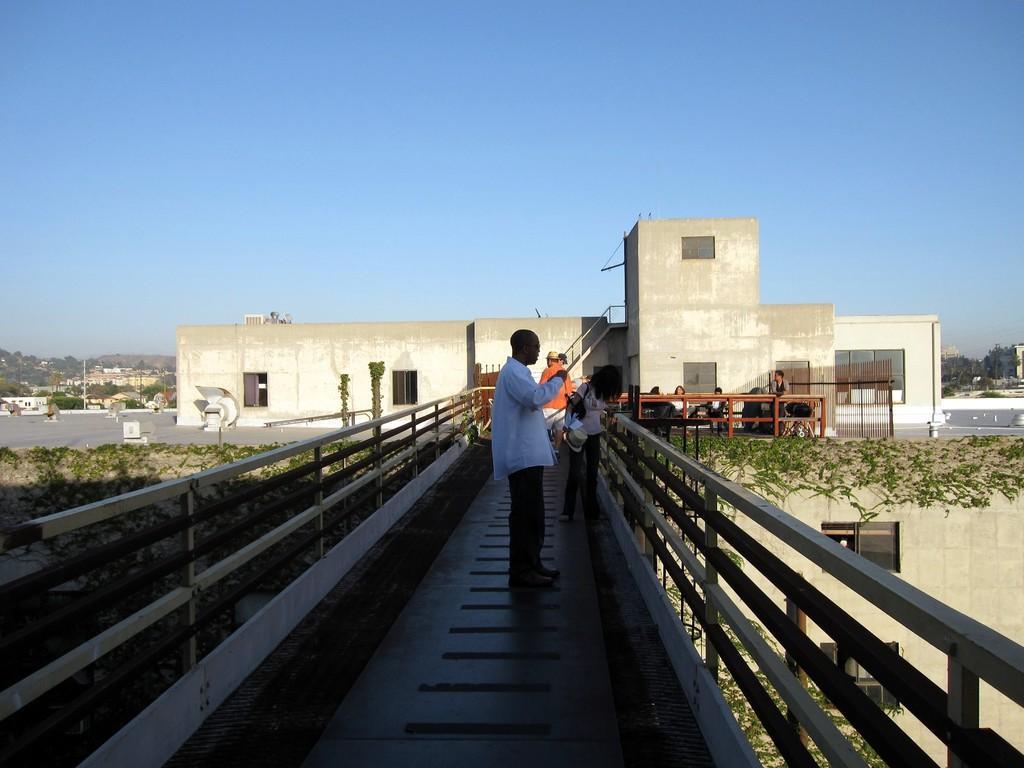Please provide a concise description of this image. In this image I can see some people. In the background, I can see the buildings, trees and the sky. 